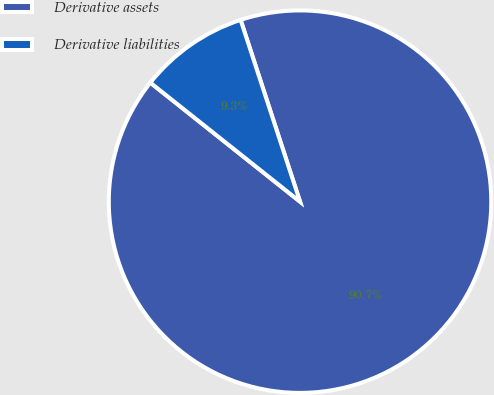Convert chart to OTSL. <chart><loc_0><loc_0><loc_500><loc_500><pie_chart><fcel>Derivative assets<fcel>Derivative liabilities<nl><fcel>90.72%<fcel>9.28%<nl></chart> 